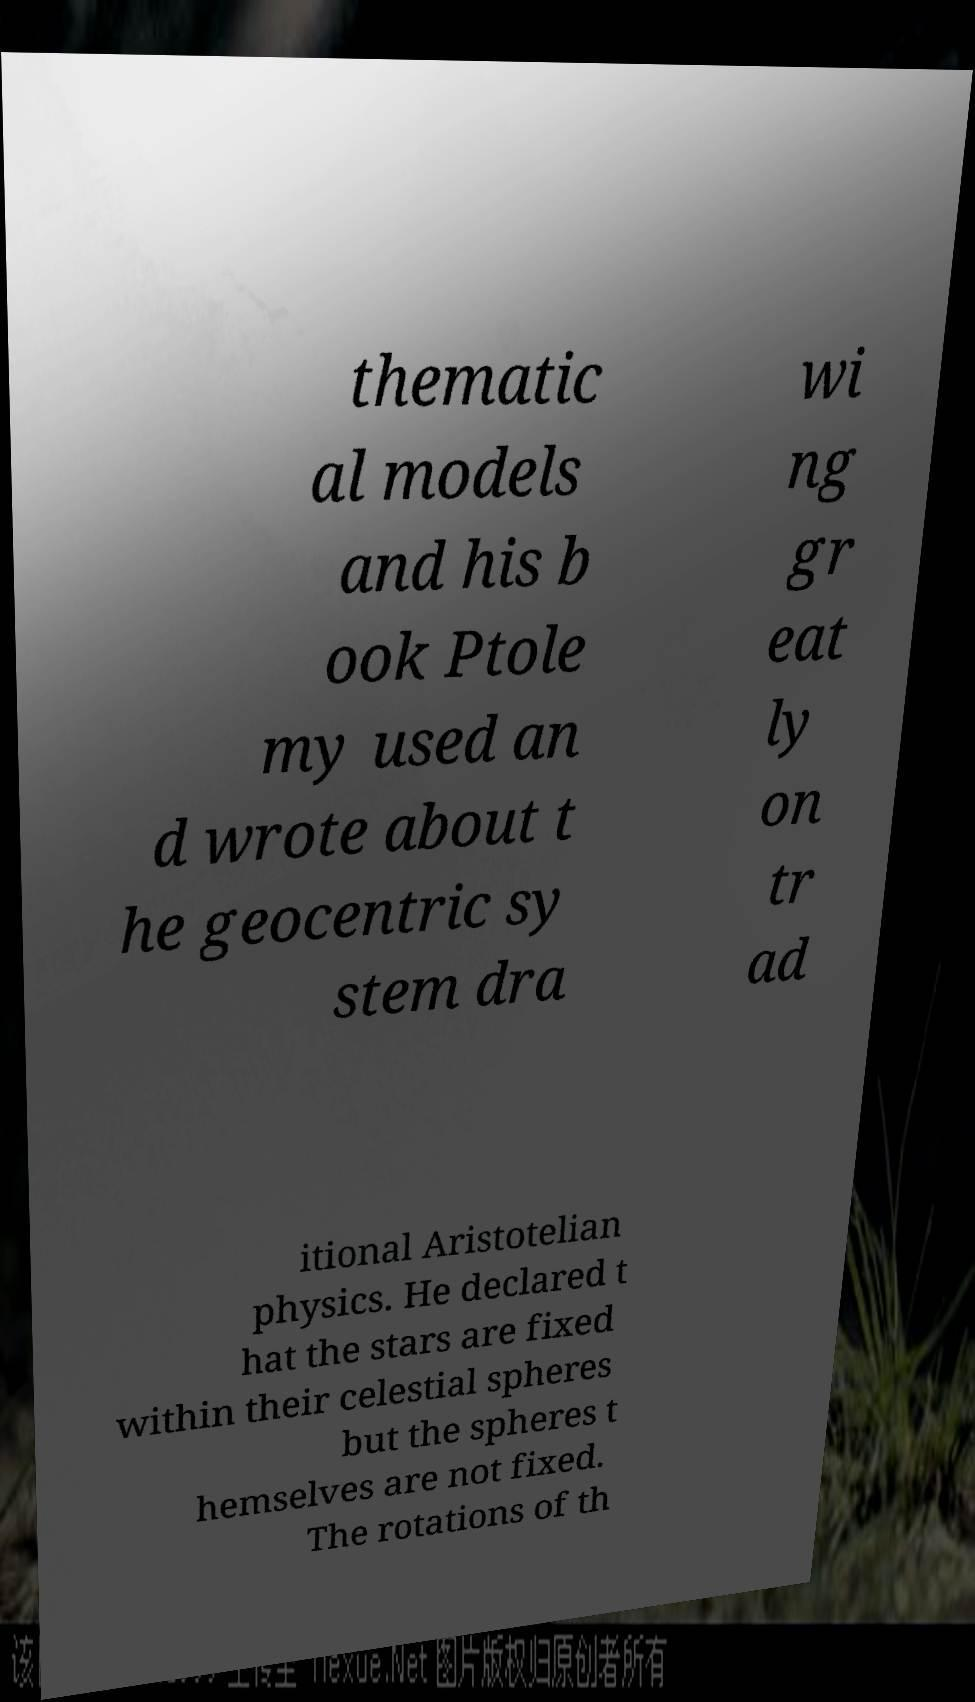For documentation purposes, I need the text within this image transcribed. Could you provide that? thematic al models and his b ook Ptole my used an d wrote about t he geocentric sy stem dra wi ng gr eat ly on tr ad itional Aristotelian physics. He declared t hat the stars are fixed within their celestial spheres but the spheres t hemselves are not fixed. The rotations of th 